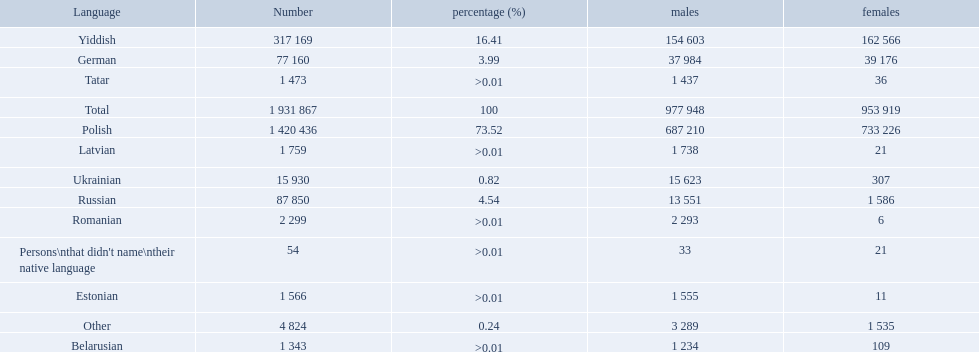What languages are spoken in the warsaw governorate? Polish, Yiddish, Russian, German, Ukrainian, Romanian, Latvian, Estonian, Tatar, Belarusian, Other, Persons\nthat didn't name\ntheir native language. What is the number for russian? 87 850. On this list what is the next lowest number? 77 160. Which language has a number of 77160 speakers? German. What are all of the languages Polish, Yiddish, Russian, German, Ukrainian, Romanian, Latvian, Estonian, Tatar, Belarusian, Other, Persons\nthat didn't name\ntheir native language. What was the percentage of each? 73.52, 16.41, 4.54, 3.99, 0.82, >0.01, >0.01, >0.01, >0.01, >0.01, 0.24, >0.01. Which languages had a >0.01	 percentage? Romanian, Latvian, Estonian, Tatar, Belarusian. And of those, which is listed first? Romanian. What languages are spoken in the warsaw governorate? Polish, Yiddish, Russian, German, Ukrainian, Romanian, Latvian, Estonian, Tatar, Belarusian. Parse the full table. {'header': ['Language', 'Number', 'percentage (%)', 'males', 'females'], 'rows': [['Yiddish', '317 169', '16.41', '154 603', '162 566'], ['German', '77 160', '3.99', '37 984', '39 176'], ['Tatar', '1 473', '>0.01', '1 437', '36'], ['Total', '1 931 867', '100', '977 948', '953 919'], ['Polish', '1 420 436', '73.52', '687 210', '733 226'], ['Latvian', '1 759', '>0.01', '1 738', '21'], ['Ukrainian', '15 930', '0.82', '15 623', '307'], ['Russian', '87 850', '4.54', '13 551', '1 586'], ['Romanian', '2 299', '>0.01', '2 293', '6'], ["Persons\\nthat didn't name\\ntheir native language", '54', '>0.01', '33', '21'], ['Estonian', '1 566', '>0.01', '1 555', '11'], ['Other', '4 824', '0.24', '3 289', '1 535'], ['Belarusian', '1 343', '>0.01', '1 234', '109']]} Which are the top five languages? Polish, Yiddish, Russian, German, Ukrainian. Of those which is the 2nd most frequently spoken? Yiddish. 